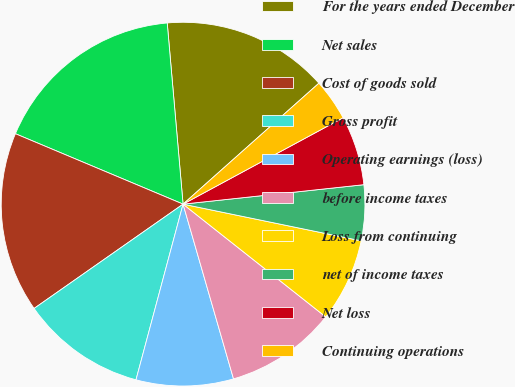<chart> <loc_0><loc_0><loc_500><loc_500><pie_chart><fcel>For the years ended December<fcel>Net sales<fcel>Cost of goods sold<fcel>Gross profit<fcel>Operating earnings (loss)<fcel>before income taxes<fcel>Loss from continuing<fcel>net of income taxes<fcel>Net loss<fcel>Continuing operations<nl><fcel>14.81%<fcel>17.28%<fcel>16.05%<fcel>11.11%<fcel>8.64%<fcel>9.88%<fcel>7.41%<fcel>4.94%<fcel>6.17%<fcel>3.7%<nl></chart> 